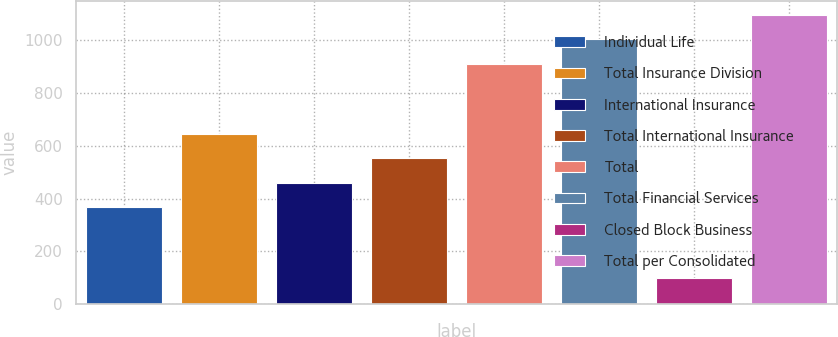Convert chart. <chart><loc_0><loc_0><loc_500><loc_500><bar_chart><fcel>Individual Life<fcel>Total Insurance Division<fcel>International Insurance<fcel>Total International Insurance<fcel>Total<fcel>Total Financial Services<fcel>Closed Block Business<fcel>Total per Consolidated<nl><fcel>369<fcel>643.2<fcel>460.4<fcel>551.8<fcel>910<fcel>1001.4<fcel>99<fcel>1092.8<nl></chart> 